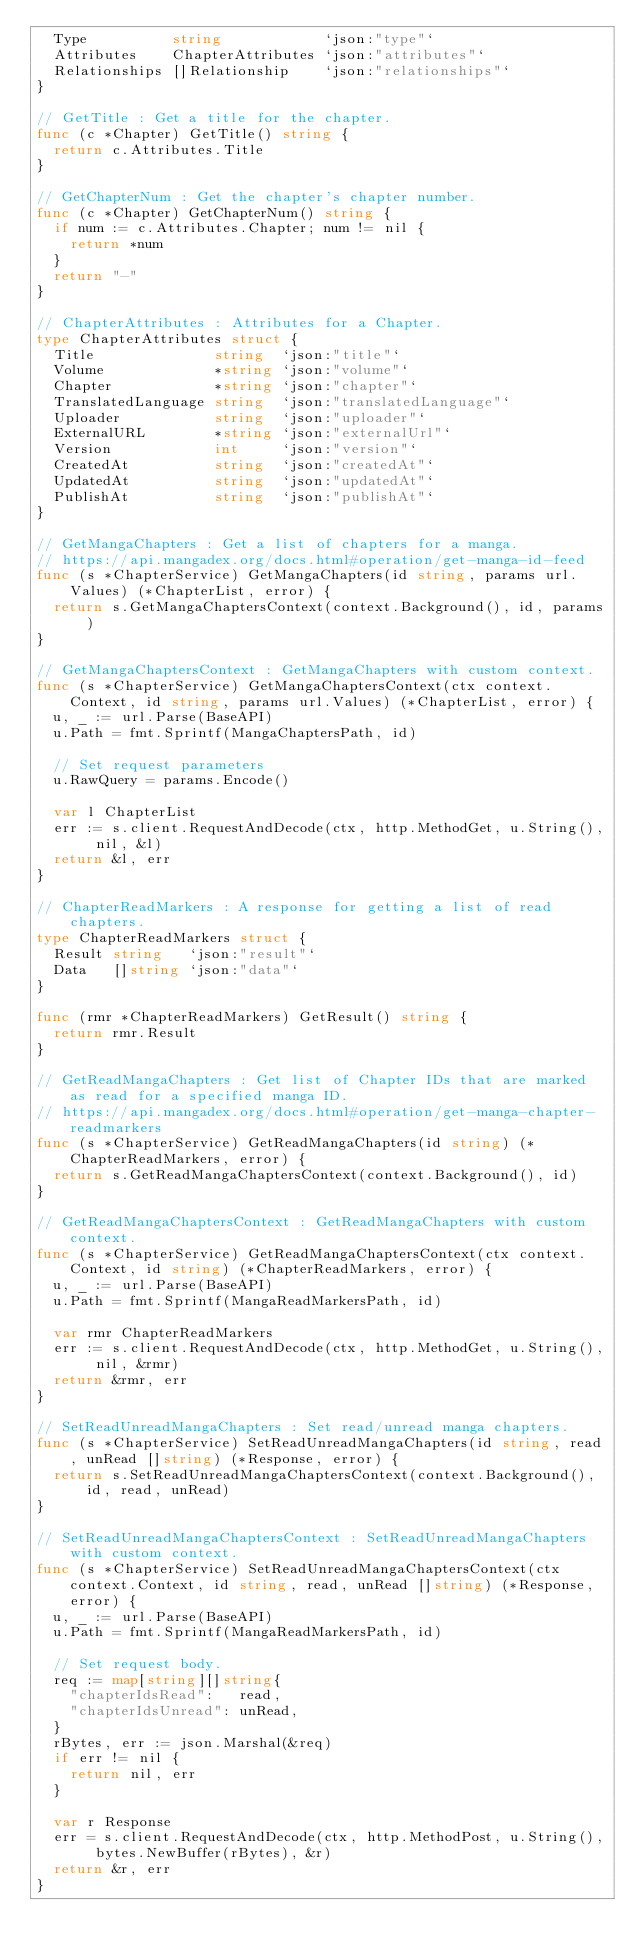Convert code to text. <code><loc_0><loc_0><loc_500><loc_500><_Go_>	Type          string            `json:"type"`
	Attributes    ChapterAttributes `json:"attributes"`
	Relationships []Relationship    `json:"relationships"`
}

// GetTitle : Get a title for the chapter.
func (c *Chapter) GetTitle() string {
	return c.Attributes.Title
}

// GetChapterNum : Get the chapter's chapter number.
func (c *Chapter) GetChapterNum() string {
	if num := c.Attributes.Chapter; num != nil {
		return *num
	}
	return "-"
}

// ChapterAttributes : Attributes for a Chapter.
type ChapterAttributes struct {
	Title              string  `json:"title"`
	Volume             *string `json:"volume"`
	Chapter            *string `json:"chapter"`
	TranslatedLanguage string  `json:"translatedLanguage"`
	Uploader           string  `json:"uploader"`
	ExternalURL        *string `json:"externalUrl"`
	Version            int     `json:"version"`
	CreatedAt          string  `json:"createdAt"`
	UpdatedAt          string  `json:"updatedAt"`
	PublishAt          string  `json:"publishAt"`
}

// GetMangaChapters : Get a list of chapters for a manga.
// https://api.mangadex.org/docs.html#operation/get-manga-id-feed
func (s *ChapterService) GetMangaChapters(id string, params url.Values) (*ChapterList, error) {
	return s.GetMangaChaptersContext(context.Background(), id, params)
}

// GetMangaChaptersContext : GetMangaChapters with custom context.
func (s *ChapterService) GetMangaChaptersContext(ctx context.Context, id string, params url.Values) (*ChapterList, error) {
	u, _ := url.Parse(BaseAPI)
	u.Path = fmt.Sprintf(MangaChaptersPath, id)

	// Set request parameters
	u.RawQuery = params.Encode()

	var l ChapterList
	err := s.client.RequestAndDecode(ctx, http.MethodGet, u.String(), nil, &l)
	return &l, err
}

// ChapterReadMarkers : A response for getting a list of read chapters.
type ChapterReadMarkers struct {
	Result string   `json:"result"`
	Data   []string `json:"data"`
}

func (rmr *ChapterReadMarkers) GetResult() string {
	return rmr.Result
}

// GetReadMangaChapters : Get list of Chapter IDs that are marked as read for a specified manga ID.
// https://api.mangadex.org/docs.html#operation/get-manga-chapter-readmarkers
func (s *ChapterService) GetReadMangaChapters(id string) (*ChapterReadMarkers, error) {
	return s.GetReadMangaChaptersContext(context.Background(), id)
}

// GetReadMangaChaptersContext : GetReadMangaChapters with custom context.
func (s *ChapterService) GetReadMangaChaptersContext(ctx context.Context, id string) (*ChapterReadMarkers, error) {
	u, _ := url.Parse(BaseAPI)
	u.Path = fmt.Sprintf(MangaReadMarkersPath, id)

	var rmr ChapterReadMarkers
	err := s.client.RequestAndDecode(ctx, http.MethodGet, u.String(), nil, &rmr)
	return &rmr, err
}

// SetReadUnreadMangaChapters : Set read/unread manga chapters.
func (s *ChapterService) SetReadUnreadMangaChapters(id string, read, unRead []string) (*Response, error) {
	return s.SetReadUnreadMangaChaptersContext(context.Background(), id, read, unRead)
}

// SetReadUnreadMangaChaptersContext : SetReadUnreadMangaChapters with custom context.
func (s *ChapterService) SetReadUnreadMangaChaptersContext(ctx context.Context, id string, read, unRead []string) (*Response, error) {
	u, _ := url.Parse(BaseAPI)
	u.Path = fmt.Sprintf(MangaReadMarkersPath, id)

	// Set request body.
	req := map[string][]string{
		"chapterIdsRead":   read,
		"chapterIdsUnread": unRead,
	}
	rBytes, err := json.Marshal(&req)
	if err != nil {
		return nil, err
	}

	var r Response
	err = s.client.RequestAndDecode(ctx, http.MethodPost, u.String(), bytes.NewBuffer(rBytes), &r)
	return &r, err
}
</code> 